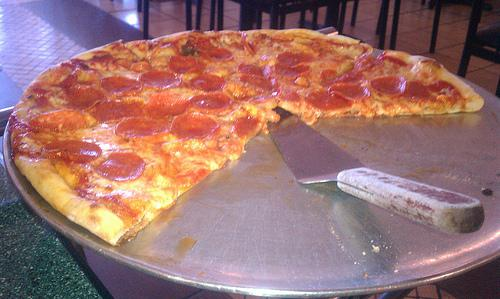Question: why is some of the pizza missing?
Choices:
A. It is being consumed.
B. It fell.
C. It wasn't paid for.
D. It was given away.
Answer with the letter. Answer: A Question: what is the orange liquid on the tray?
Choices:
A. Fat residue from the pizza.
B. Grease.
C. Orange soda.
D. Orange jam.
Answer with the letter. Answer: A Question: where was this taken?
Choices:
A. At a club.
B. At a bar.
C. At the park.
D. In a restaurant.
Answer with the letter. Answer: D Question: when was this taken?
Choices:
A. At night.
B. Dawn.
C. Dusk.
D. During the day.
Answer with the letter. Answer: D Question: what is the handle of the pizza server made from?
Choices:
A. Wood.
B. Metal.
C. Ceramic.
D. Plastic.
Answer with the letter. Answer: A Question: what is the serving tray made from?
Choices:
A. Wood.
B. Plastic.
C. Metal.
D. Ceramic.
Answer with the letter. Answer: C 